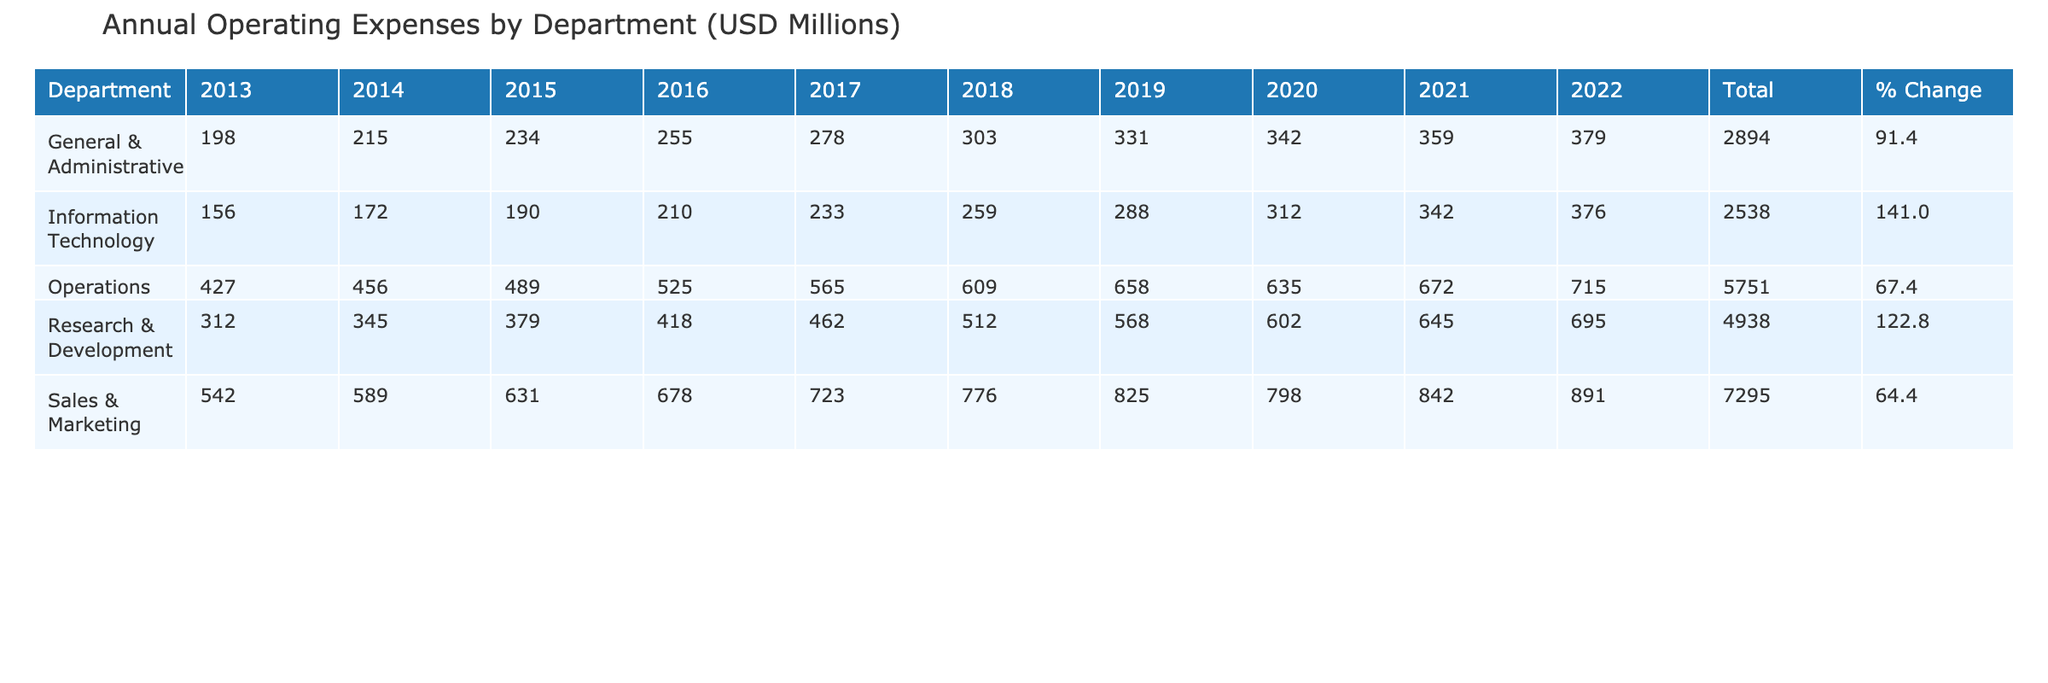What's the total operating expenses for Sales & Marketing in 2022? The table shows that the operating expenses for Sales & Marketing in 2022 are 891 million USD.
Answer: 891 million USD How much did the Research & Development expenses increase from 2013 to 2022? The expenses in 2013 were 312 million USD and in 2022 they are 695 million USD. The increase is 695 - 312 = 383 million USD.
Answer: 383 million USD Which department had the highest total operating expenses over the decade? By summing the total expenses for each department, Sales & Marketing has the highest total of 8,436 million USD.
Answer: Sales & Marketing What is the percentage change in operating expenses for Operations from 2013 to 2022? The operating expenses in 2013 were 427 million USD and in 2022 they are 715 million USD. The percentage change is ((715 - 427) / 427) * 100 = 67.5%.
Answer: 67.5% Did General & Administrative expenses exceed 400 million USD in any year? The table shows the maximum expenses were 379 million USD in 2022, which is below 400 million USD. Hence, the expenses never exceeded 400 million USD.
Answer: No What was the average annual operating expense for Information Technology from 2013 to 2022? The total expenses from 2013 to 2022 are (156 + 172 + 190 + 210 + 233 + 259 + 288 + 312 + 342 + 376) = 2188 million USD. To find the average, divide by 10, which results in 218.8 million USD.
Answer: 218.8 million USD Which department saw the smallest percentage increase in operating expenses over the decade? By comparing the percentage changes: Sales & Marketing at 64.4%, Research & Development at 122.0%, General & Administrative at 91.4%, Operations at 67.5%, and Information Technology at 141.0%. Therefore, Sales & Marketing has the smallest percentage increase.
Answer: Sales & Marketing What were the total operating expenses for Operations across the last two years (2021 and 2022)? The operating expenses for Operations in 2021 are 672 million USD and in 2022 are 715 million USD. The total is 672 + 715 = 1387 million USD.
Answer: 1387 million USD For which department is the operating expense higher in 2021 compared to 2020? Checking the values, Sales & Marketing increased from 798 to 842 million, Research & Development from 602 to 645 million, General & Administrative from 342 to 359 million, Operations from 635 to 672 million, and Information Technology from 312 to 342 million. All departments had higher expenses in 2021 compared to 2020.
Answer: All departments How do the operating expenses for Sales & Marketing compare to General & Administrative in 2022? In 2022, Sales & Marketing expenses are 891 million USD and General & Administrative expenses are 379 million USD. The difference is 891 - 379 = 512 million USD, indicating Sales & Marketing spent significantly more.
Answer: Sales & Marketing spent 512 million USD more 